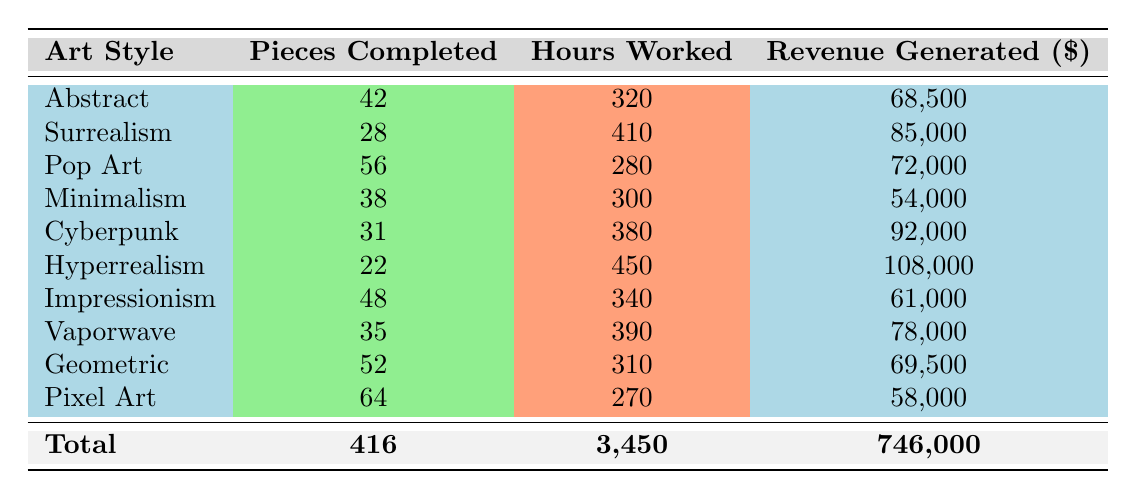What is the total revenue generated by all artists? To calculate the total revenue generated by all artists, we sum the revenue generated by each artist: 68500 + 85000 + 72000 + 54000 + 92000 + 108000 + 61000 + 78000 + 69500 + 58000 = 746000.
Answer: 746000 Which artist completed the highest number of pieces? By comparing the 'Pieces Completed' column, Ethan Williams completed the highest number of pieces, totaling 64.
Answer: Ethan Williams Is the revenue generated by the Minimalism art style higher than that of the Impressionism art style? Minimalism generated 54000, while Impressionism generated 61000. Since 54000 is less than 61000, the answer is no.
Answer: No What is the average revenue generated per art style? To find the average revenue per art style, we divide the total revenue (746000) by the number of art styles (10): 746000 / 10 = 74600.
Answer: 74600 Which art style had the highest hours worked? By checking the 'Hours Worked' column, Hyperrealism had the most hours worked, totaling 450 hours.
Answer: Hyperrealism Did any artists generate more than 90000 in revenue? Checking the revenue generated, both Olivia Kim (92000) and Lucas Dubois (108000) generated more than 90000. Therefore, the answer is yes.
Answer: Yes What is the difference in the number of pieces completed between the artist with the most and the artist with the least pieces completed? The artist with the most completed pieces is Ethan Williams (64), and the artist with the least is Lucas Dubois (22). The difference is 64 - 22 = 42.
Answer: 42 How many artists worked less than 300 hours? By examining the table, the artists who worked less than 300 hours are Ethan Williams (270 hours) and Aiden Patel (300 hours, not included), totaling 1 artist.
Answer: 1 Which art style has the second highest revenue generated? The revenues generated by art styles in descending order: Hyperrealism (108000), Cyberpunk (92000), Surrealism (85000), Pop Art (72000), therefore Cyberpunk has the second highest revenue.
Answer: Cyberpunk 